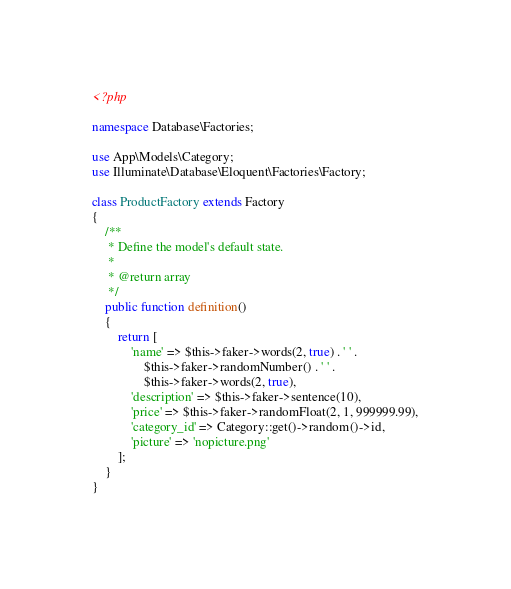<code> <loc_0><loc_0><loc_500><loc_500><_PHP_><?php

namespace Database\Factories;

use App\Models\Category;
use Illuminate\Database\Eloquent\Factories\Factory;

class ProductFactory extends Factory
{
    /**
     * Define the model's default state.
     *
     * @return array
     */
    public function definition()
    {
        return [
            'name' => $this->faker->words(2, true) . ' ' .
                $this->faker->randomNumber() . ' ' .
                $this->faker->words(2, true),
            'description' => $this->faker->sentence(10),
            'price' => $this->faker->randomFloat(2, 1, 999999.99),
            'category_id' => Category::get()->random()->id,
            'picture' => 'nopicture.png'
        ];
    }
}
</code> 